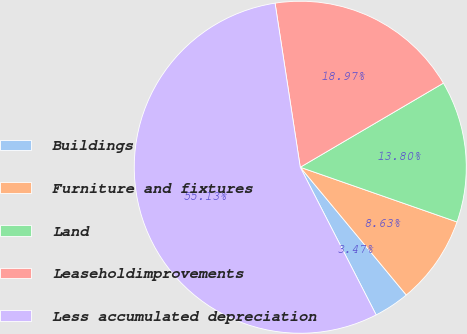Convert chart to OTSL. <chart><loc_0><loc_0><loc_500><loc_500><pie_chart><fcel>Buildings<fcel>Furniture and fixtures<fcel>Land<fcel>Leaseholdimprovements<fcel>Less accumulated depreciation<nl><fcel>3.47%<fcel>8.63%<fcel>13.8%<fcel>18.97%<fcel>55.13%<nl></chart> 